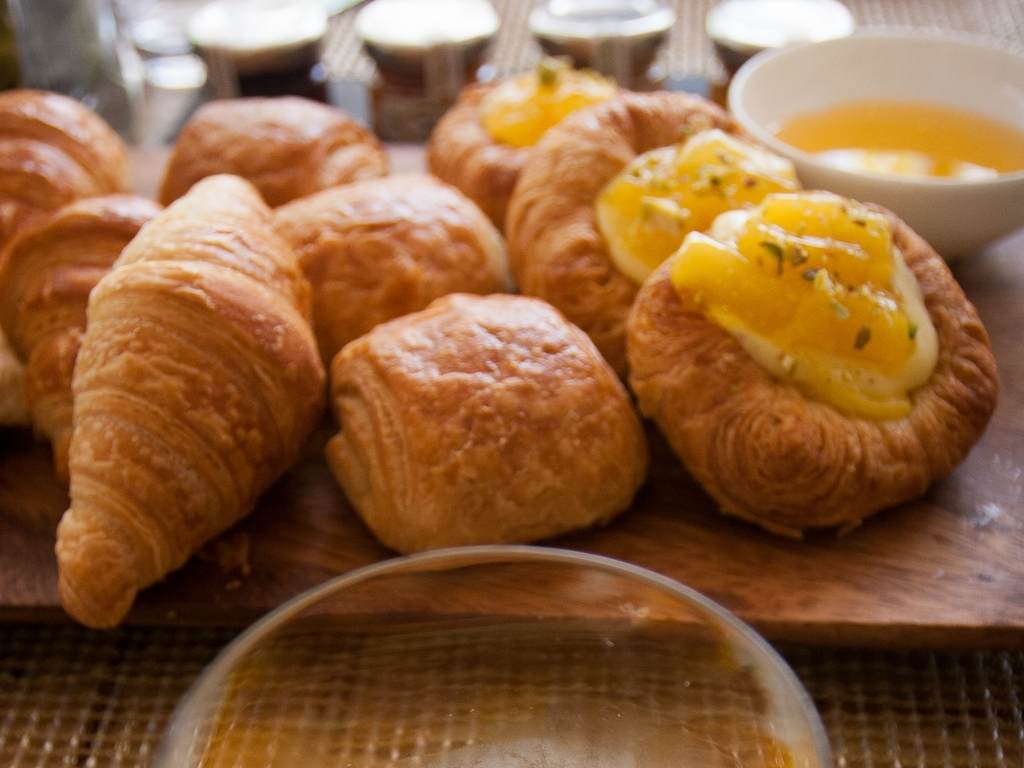What time of day or occasion do you think this image relates to? This image seems to be perfectly suited for a morning setting, probably capturing a moment during a delectable breakfast or a leisurely brunch. The presence of croissants, often associated with breakfast, and the casual arrangement suggests an inviting start to the day centered around comfort and good food. 